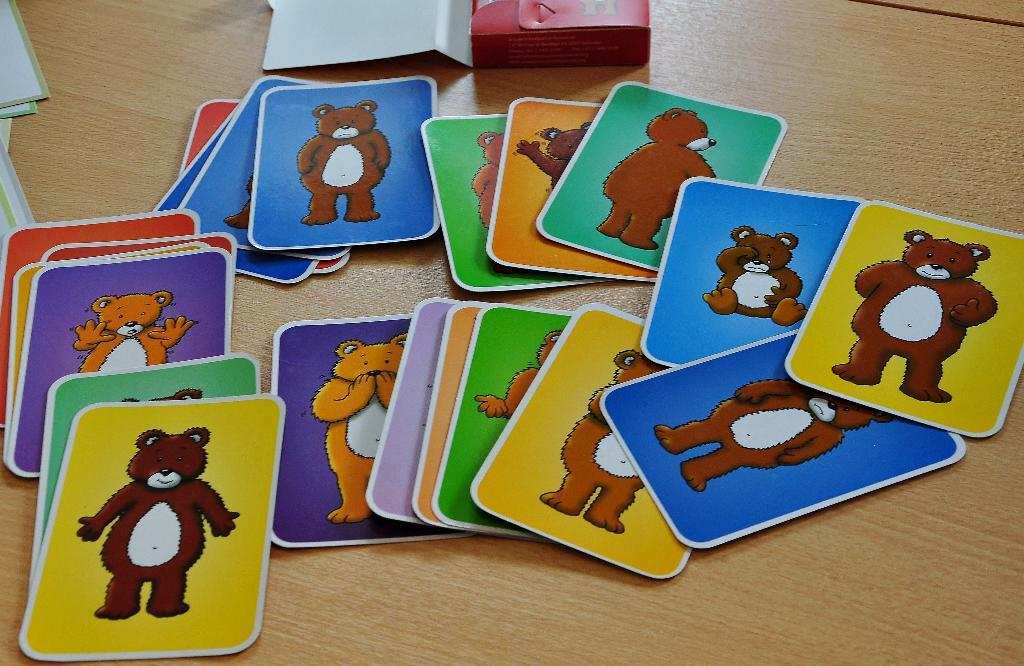What objects are present in the image? There are cards in the image. Can you describe the appearance of the cards? The cards have different colors and a teddy bear image on them. Where are the cards located in the image? The cards are placed on a surface. How many deer can be seen in the image? There are no deer present in the image; it features cards with a teddy bear image. What level of experience is required to use the cards in the image? The facts provided do not indicate the level of experience required to use the cards, as they only mention the appearance and location of the cards. 